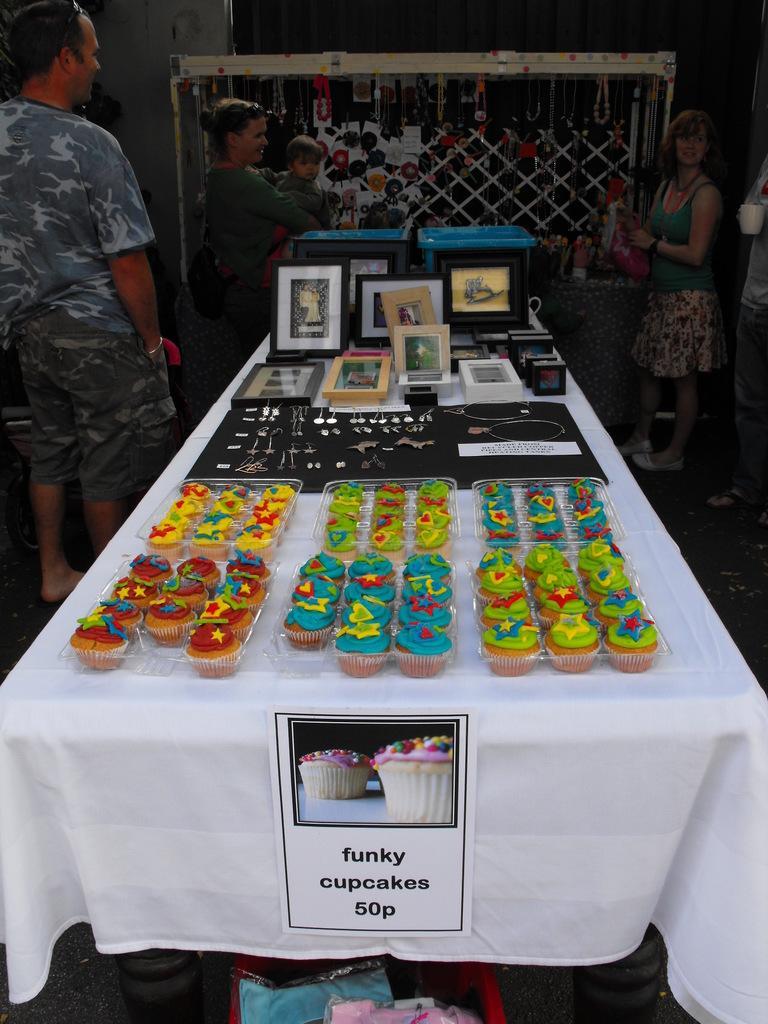Describe this image in one or two sentences. Here we can see few persons standing in front of a table and on the table we can see few items and also in box there are cupcakes. This is a white cloth on the table. This is a basket. Here we can see one woman is holding a baby in her hands. 